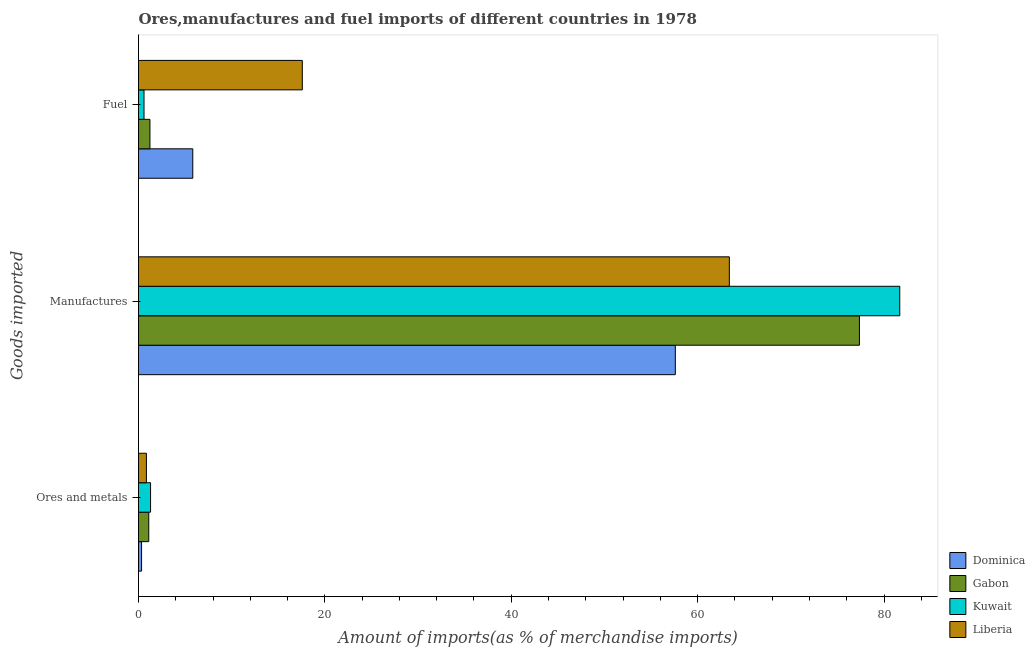How many different coloured bars are there?
Make the answer very short. 4. How many groups of bars are there?
Your answer should be very brief. 3. Are the number of bars per tick equal to the number of legend labels?
Provide a short and direct response. Yes. How many bars are there on the 2nd tick from the top?
Your answer should be very brief. 4. How many bars are there on the 3rd tick from the bottom?
Offer a terse response. 4. What is the label of the 2nd group of bars from the top?
Your answer should be compact. Manufactures. What is the percentage of ores and metals imports in Kuwait?
Keep it short and to the point. 1.29. Across all countries, what is the maximum percentage of ores and metals imports?
Offer a terse response. 1.29. Across all countries, what is the minimum percentage of fuel imports?
Your response must be concise. 0.59. In which country was the percentage of fuel imports maximum?
Keep it short and to the point. Liberia. In which country was the percentage of manufactures imports minimum?
Provide a short and direct response. Dominica. What is the total percentage of fuel imports in the graph?
Your answer should be very brief. 25.22. What is the difference between the percentage of manufactures imports in Kuwait and that in Liberia?
Offer a very short reply. 18.29. What is the difference between the percentage of fuel imports in Kuwait and the percentage of ores and metals imports in Dominica?
Make the answer very short. 0.26. What is the average percentage of manufactures imports per country?
Your answer should be compact. 70.02. What is the difference between the percentage of ores and metals imports and percentage of fuel imports in Gabon?
Provide a succinct answer. -0.13. In how many countries, is the percentage of fuel imports greater than 52 %?
Provide a succinct answer. 0. What is the ratio of the percentage of fuel imports in Dominica to that in Gabon?
Give a very brief answer. 4.75. Is the percentage of fuel imports in Gabon less than that in Kuwait?
Make the answer very short. No. What is the difference between the highest and the second highest percentage of fuel imports?
Offer a very short reply. 11.75. What is the difference between the highest and the lowest percentage of manufactures imports?
Your response must be concise. 24.09. What does the 2nd bar from the top in Manufactures represents?
Offer a terse response. Kuwait. What does the 4th bar from the bottom in Ores and metals represents?
Make the answer very short. Liberia. Is it the case that in every country, the sum of the percentage of ores and metals imports and percentage of manufactures imports is greater than the percentage of fuel imports?
Your response must be concise. Yes. How many bars are there?
Ensure brevity in your answer.  12. How many countries are there in the graph?
Keep it short and to the point. 4. What is the difference between two consecutive major ticks on the X-axis?
Give a very brief answer. 20. Does the graph contain any zero values?
Provide a short and direct response. No. How are the legend labels stacked?
Your answer should be very brief. Vertical. What is the title of the graph?
Provide a succinct answer. Ores,manufactures and fuel imports of different countries in 1978. What is the label or title of the X-axis?
Provide a succinct answer. Amount of imports(as % of merchandise imports). What is the label or title of the Y-axis?
Your answer should be compact. Goods imported. What is the Amount of imports(as % of merchandise imports) in Dominica in Ores and metals?
Make the answer very short. 0.33. What is the Amount of imports(as % of merchandise imports) of Gabon in Ores and metals?
Your answer should be very brief. 1.1. What is the Amount of imports(as % of merchandise imports) in Kuwait in Ores and metals?
Ensure brevity in your answer.  1.29. What is the Amount of imports(as % of merchandise imports) of Liberia in Ores and metals?
Your answer should be very brief. 0.85. What is the Amount of imports(as % of merchandise imports) of Dominica in Manufactures?
Your response must be concise. 57.61. What is the Amount of imports(as % of merchandise imports) of Gabon in Manufactures?
Offer a terse response. 77.36. What is the Amount of imports(as % of merchandise imports) of Kuwait in Manufactures?
Make the answer very short. 81.69. What is the Amount of imports(as % of merchandise imports) of Liberia in Manufactures?
Give a very brief answer. 63.4. What is the Amount of imports(as % of merchandise imports) of Dominica in Fuel?
Offer a very short reply. 5.82. What is the Amount of imports(as % of merchandise imports) in Gabon in Fuel?
Your response must be concise. 1.23. What is the Amount of imports(as % of merchandise imports) in Kuwait in Fuel?
Offer a terse response. 0.59. What is the Amount of imports(as % of merchandise imports) of Liberia in Fuel?
Your answer should be compact. 17.58. Across all Goods imported, what is the maximum Amount of imports(as % of merchandise imports) in Dominica?
Your response must be concise. 57.61. Across all Goods imported, what is the maximum Amount of imports(as % of merchandise imports) of Gabon?
Ensure brevity in your answer.  77.36. Across all Goods imported, what is the maximum Amount of imports(as % of merchandise imports) in Kuwait?
Offer a terse response. 81.69. Across all Goods imported, what is the maximum Amount of imports(as % of merchandise imports) of Liberia?
Offer a terse response. 63.4. Across all Goods imported, what is the minimum Amount of imports(as % of merchandise imports) in Dominica?
Your answer should be very brief. 0.33. Across all Goods imported, what is the minimum Amount of imports(as % of merchandise imports) of Gabon?
Keep it short and to the point. 1.1. Across all Goods imported, what is the minimum Amount of imports(as % of merchandise imports) in Kuwait?
Your answer should be very brief. 0.59. Across all Goods imported, what is the minimum Amount of imports(as % of merchandise imports) of Liberia?
Provide a short and direct response. 0.85. What is the total Amount of imports(as % of merchandise imports) in Dominica in the graph?
Offer a very short reply. 63.76. What is the total Amount of imports(as % of merchandise imports) of Gabon in the graph?
Provide a succinct answer. 79.69. What is the total Amount of imports(as % of merchandise imports) in Kuwait in the graph?
Give a very brief answer. 83.58. What is the total Amount of imports(as % of merchandise imports) in Liberia in the graph?
Provide a succinct answer. 81.83. What is the difference between the Amount of imports(as % of merchandise imports) of Dominica in Ores and metals and that in Manufactures?
Keep it short and to the point. -57.28. What is the difference between the Amount of imports(as % of merchandise imports) of Gabon in Ores and metals and that in Manufactures?
Give a very brief answer. -76.26. What is the difference between the Amount of imports(as % of merchandise imports) of Kuwait in Ores and metals and that in Manufactures?
Provide a succinct answer. -80.4. What is the difference between the Amount of imports(as % of merchandise imports) of Liberia in Ores and metals and that in Manufactures?
Give a very brief answer. -62.56. What is the difference between the Amount of imports(as % of merchandise imports) in Dominica in Ores and metals and that in Fuel?
Ensure brevity in your answer.  -5.5. What is the difference between the Amount of imports(as % of merchandise imports) of Gabon in Ores and metals and that in Fuel?
Make the answer very short. -0.13. What is the difference between the Amount of imports(as % of merchandise imports) of Kuwait in Ores and metals and that in Fuel?
Keep it short and to the point. 0.7. What is the difference between the Amount of imports(as % of merchandise imports) in Liberia in Ores and metals and that in Fuel?
Keep it short and to the point. -16.73. What is the difference between the Amount of imports(as % of merchandise imports) of Dominica in Manufactures and that in Fuel?
Your answer should be compact. 51.78. What is the difference between the Amount of imports(as % of merchandise imports) in Gabon in Manufactures and that in Fuel?
Provide a succinct answer. 76.14. What is the difference between the Amount of imports(as % of merchandise imports) of Kuwait in Manufactures and that in Fuel?
Your response must be concise. 81.1. What is the difference between the Amount of imports(as % of merchandise imports) of Liberia in Manufactures and that in Fuel?
Offer a terse response. 45.82. What is the difference between the Amount of imports(as % of merchandise imports) of Dominica in Ores and metals and the Amount of imports(as % of merchandise imports) of Gabon in Manufactures?
Your answer should be very brief. -77.04. What is the difference between the Amount of imports(as % of merchandise imports) of Dominica in Ores and metals and the Amount of imports(as % of merchandise imports) of Kuwait in Manufactures?
Your answer should be very brief. -81.36. What is the difference between the Amount of imports(as % of merchandise imports) of Dominica in Ores and metals and the Amount of imports(as % of merchandise imports) of Liberia in Manufactures?
Make the answer very short. -63.08. What is the difference between the Amount of imports(as % of merchandise imports) of Gabon in Ores and metals and the Amount of imports(as % of merchandise imports) of Kuwait in Manufactures?
Your response must be concise. -80.59. What is the difference between the Amount of imports(as % of merchandise imports) in Gabon in Ores and metals and the Amount of imports(as % of merchandise imports) in Liberia in Manufactures?
Your answer should be compact. -62.3. What is the difference between the Amount of imports(as % of merchandise imports) of Kuwait in Ores and metals and the Amount of imports(as % of merchandise imports) of Liberia in Manufactures?
Offer a very short reply. -62.11. What is the difference between the Amount of imports(as % of merchandise imports) of Dominica in Ores and metals and the Amount of imports(as % of merchandise imports) of Gabon in Fuel?
Ensure brevity in your answer.  -0.9. What is the difference between the Amount of imports(as % of merchandise imports) of Dominica in Ores and metals and the Amount of imports(as % of merchandise imports) of Kuwait in Fuel?
Offer a terse response. -0.26. What is the difference between the Amount of imports(as % of merchandise imports) in Dominica in Ores and metals and the Amount of imports(as % of merchandise imports) in Liberia in Fuel?
Make the answer very short. -17.25. What is the difference between the Amount of imports(as % of merchandise imports) in Gabon in Ores and metals and the Amount of imports(as % of merchandise imports) in Kuwait in Fuel?
Make the answer very short. 0.51. What is the difference between the Amount of imports(as % of merchandise imports) in Gabon in Ores and metals and the Amount of imports(as % of merchandise imports) in Liberia in Fuel?
Your response must be concise. -16.48. What is the difference between the Amount of imports(as % of merchandise imports) of Kuwait in Ores and metals and the Amount of imports(as % of merchandise imports) of Liberia in Fuel?
Make the answer very short. -16.29. What is the difference between the Amount of imports(as % of merchandise imports) of Dominica in Manufactures and the Amount of imports(as % of merchandise imports) of Gabon in Fuel?
Your answer should be compact. 56.38. What is the difference between the Amount of imports(as % of merchandise imports) of Dominica in Manufactures and the Amount of imports(as % of merchandise imports) of Kuwait in Fuel?
Provide a short and direct response. 57.01. What is the difference between the Amount of imports(as % of merchandise imports) of Dominica in Manufactures and the Amount of imports(as % of merchandise imports) of Liberia in Fuel?
Provide a succinct answer. 40.03. What is the difference between the Amount of imports(as % of merchandise imports) in Gabon in Manufactures and the Amount of imports(as % of merchandise imports) in Kuwait in Fuel?
Give a very brief answer. 76.77. What is the difference between the Amount of imports(as % of merchandise imports) of Gabon in Manufactures and the Amount of imports(as % of merchandise imports) of Liberia in Fuel?
Your answer should be very brief. 59.78. What is the difference between the Amount of imports(as % of merchandise imports) of Kuwait in Manufactures and the Amount of imports(as % of merchandise imports) of Liberia in Fuel?
Offer a very short reply. 64.11. What is the average Amount of imports(as % of merchandise imports) of Dominica per Goods imported?
Keep it short and to the point. 21.25. What is the average Amount of imports(as % of merchandise imports) in Gabon per Goods imported?
Keep it short and to the point. 26.56. What is the average Amount of imports(as % of merchandise imports) of Kuwait per Goods imported?
Offer a terse response. 27.86. What is the average Amount of imports(as % of merchandise imports) in Liberia per Goods imported?
Keep it short and to the point. 27.28. What is the difference between the Amount of imports(as % of merchandise imports) in Dominica and Amount of imports(as % of merchandise imports) in Gabon in Ores and metals?
Provide a succinct answer. -0.77. What is the difference between the Amount of imports(as % of merchandise imports) of Dominica and Amount of imports(as % of merchandise imports) of Kuwait in Ores and metals?
Your response must be concise. -0.97. What is the difference between the Amount of imports(as % of merchandise imports) of Dominica and Amount of imports(as % of merchandise imports) of Liberia in Ores and metals?
Your answer should be very brief. -0.52. What is the difference between the Amount of imports(as % of merchandise imports) in Gabon and Amount of imports(as % of merchandise imports) in Kuwait in Ores and metals?
Your answer should be very brief. -0.19. What is the difference between the Amount of imports(as % of merchandise imports) in Gabon and Amount of imports(as % of merchandise imports) in Liberia in Ores and metals?
Ensure brevity in your answer.  0.25. What is the difference between the Amount of imports(as % of merchandise imports) of Kuwait and Amount of imports(as % of merchandise imports) of Liberia in Ores and metals?
Offer a terse response. 0.45. What is the difference between the Amount of imports(as % of merchandise imports) in Dominica and Amount of imports(as % of merchandise imports) in Gabon in Manufactures?
Keep it short and to the point. -19.76. What is the difference between the Amount of imports(as % of merchandise imports) in Dominica and Amount of imports(as % of merchandise imports) in Kuwait in Manufactures?
Offer a very short reply. -24.09. What is the difference between the Amount of imports(as % of merchandise imports) of Dominica and Amount of imports(as % of merchandise imports) of Liberia in Manufactures?
Your answer should be very brief. -5.8. What is the difference between the Amount of imports(as % of merchandise imports) of Gabon and Amount of imports(as % of merchandise imports) of Kuwait in Manufactures?
Make the answer very short. -4.33. What is the difference between the Amount of imports(as % of merchandise imports) in Gabon and Amount of imports(as % of merchandise imports) in Liberia in Manufactures?
Provide a short and direct response. 13.96. What is the difference between the Amount of imports(as % of merchandise imports) of Kuwait and Amount of imports(as % of merchandise imports) of Liberia in Manufactures?
Provide a short and direct response. 18.29. What is the difference between the Amount of imports(as % of merchandise imports) in Dominica and Amount of imports(as % of merchandise imports) in Gabon in Fuel?
Keep it short and to the point. 4.6. What is the difference between the Amount of imports(as % of merchandise imports) in Dominica and Amount of imports(as % of merchandise imports) in Kuwait in Fuel?
Make the answer very short. 5.23. What is the difference between the Amount of imports(as % of merchandise imports) of Dominica and Amount of imports(as % of merchandise imports) of Liberia in Fuel?
Offer a terse response. -11.75. What is the difference between the Amount of imports(as % of merchandise imports) in Gabon and Amount of imports(as % of merchandise imports) in Kuwait in Fuel?
Your response must be concise. 0.63. What is the difference between the Amount of imports(as % of merchandise imports) in Gabon and Amount of imports(as % of merchandise imports) in Liberia in Fuel?
Keep it short and to the point. -16.35. What is the difference between the Amount of imports(as % of merchandise imports) of Kuwait and Amount of imports(as % of merchandise imports) of Liberia in Fuel?
Ensure brevity in your answer.  -16.99. What is the ratio of the Amount of imports(as % of merchandise imports) of Dominica in Ores and metals to that in Manufactures?
Your response must be concise. 0.01. What is the ratio of the Amount of imports(as % of merchandise imports) in Gabon in Ores and metals to that in Manufactures?
Offer a terse response. 0.01. What is the ratio of the Amount of imports(as % of merchandise imports) of Kuwait in Ores and metals to that in Manufactures?
Offer a very short reply. 0.02. What is the ratio of the Amount of imports(as % of merchandise imports) in Liberia in Ores and metals to that in Manufactures?
Your answer should be compact. 0.01. What is the ratio of the Amount of imports(as % of merchandise imports) of Dominica in Ores and metals to that in Fuel?
Your answer should be compact. 0.06. What is the ratio of the Amount of imports(as % of merchandise imports) in Gabon in Ores and metals to that in Fuel?
Ensure brevity in your answer.  0.9. What is the ratio of the Amount of imports(as % of merchandise imports) of Kuwait in Ores and metals to that in Fuel?
Keep it short and to the point. 2.18. What is the ratio of the Amount of imports(as % of merchandise imports) of Liberia in Ores and metals to that in Fuel?
Keep it short and to the point. 0.05. What is the ratio of the Amount of imports(as % of merchandise imports) in Dominica in Manufactures to that in Fuel?
Provide a short and direct response. 9.89. What is the ratio of the Amount of imports(as % of merchandise imports) in Gabon in Manufactures to that in Fuel?
Ensure brevity in your answer.  63.06. What is the ratio of the Amount of imports(as % of merchandise imports) in Kuwait in Manufactures to that in Fuel?
Your answer should be compact. 138.04. What is the ratio of the Amount of imports(as % of merchandise imports) of Liberia in Manufactures to that in Fuel?
Make the answer very short. 3.61. What is the difference between the highest and the second highest Amount of imports(as % of merchandise imports) in Dominica?
Make the answer very short. 51.78. What is the difference between the highest and the second highest Amount of imports(as % of merchandise imports) in Gabon?
Offer a terse response. 76.14. What is the difference between the highest and the second highest Amount of imports(as % of merchandise imports) of Kuwait?
Your response must be concise. 80.4. What is the difference between the highest and the second highest Amount of imports(as % of merchandise imports) of Liberia?
Keep it short and to the point. 45.82. What is the difference between the highest and the lowest Amount of imports(as % of merchandise imports) of Dominica?
Keep it short and to the point. 57.28. What is the difference between the highest and the lowest Amount of imports(as % of merchandise imports) in Gabon?
Make the answer very short. 76.26. What is the difference between the highest and the lowest Amount of imports(as % of merchandise imports) in Kuwait?
Your response must be concise. 81.1. What is the difference between the highest and the lowest Amount of imports(as % of merchandise imports) of Liberia?
Make the answer very short. 62.56. 